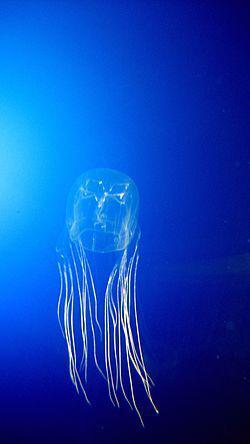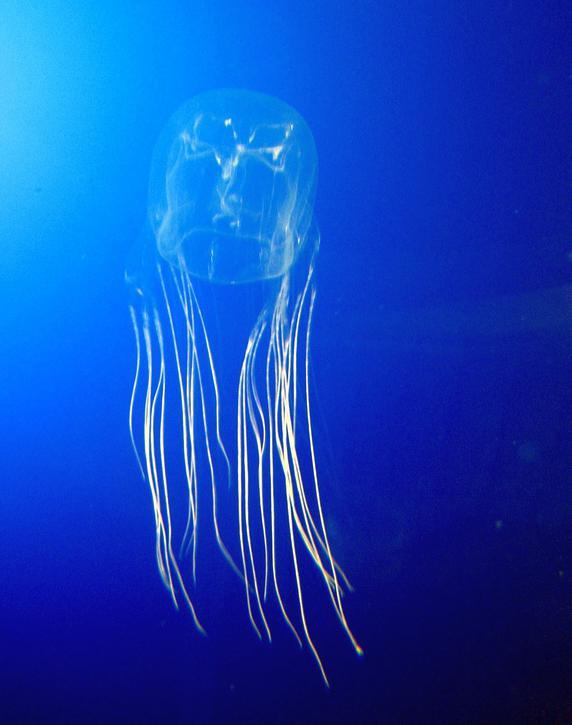The first image is the image on the left, the second image is the image on the right. For the images displayed, is the sentence "There are exactly two jellyfish and no humans, and at least one jellyfish is facing to the right." factually correct? Answer yes or no. No. 